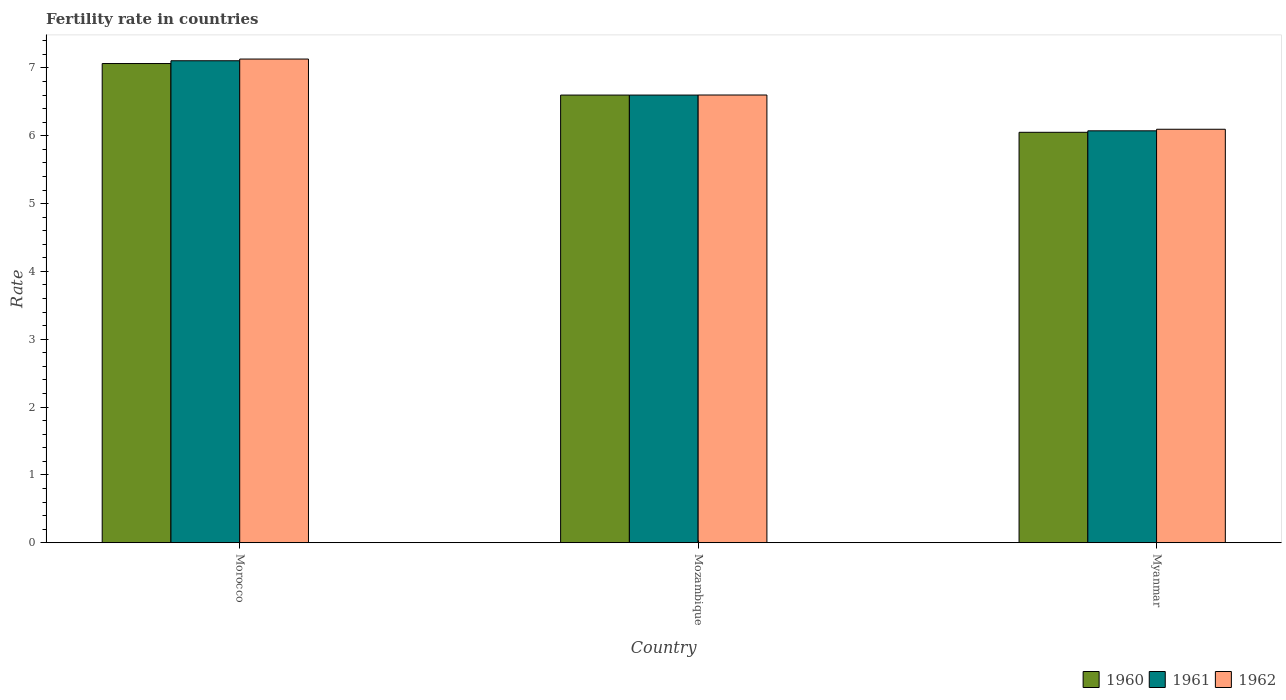How many groups of bars are there?
Give a very brief answer. 3. Are the number of bars on each tick of the X-axis equal?
Your answer should be compact. Yes. What is the label of the 1st group of bars from the left?
Provide a succinct answer. Morocco. What is the fertility rate in 1960 in Myanmar?
Make the answer very short. 6.05. Across all countries, what is the maximum fertility rate in 1960?
Your response must be concise. 7.07. Across all countries, what is the minimum fertility rate in 1961?
Offer a very short reply. 6.07. In which country was the fertility rate in 1962 maximum?
Keep it short and to the point. Morocco. In which country was the fertility rate in 1960 minimum?
Ensure brevity in your answer.  Myanmar. What is the total fertility rate in 1960 in the graph?
Offer a terse response. 19.72. What is the difference between the fertility rate in 1960 in Mozambique and that in Myanmar?
Offer a very short reply. 0.55. What is the difference between the fertility rate in 1960 in Myanmar and the fertility rate in 1961 in Mozambique?
Your response must be concise. -0.55. What is the average fertility rate in 1961 per country?
Provide a succinct answer. 6.59. What is the difference between the fertility rate of/in 1960 and fertility rate of/in 1961 in Mozambique?
Ensure brevity in your answer.  0. What is the ratio of the fertility rate in 1960 in Morocco to that in Myanmar?
Make the answer very short. 1.17. What is the difference between the highest and the second highest fertility rate in 1962?
Your answer should be compact. -0.5. What is the difference between the highest and the lowest fertility rate in 1960?
Keep it short and to the point. 1.01. In how many countries, is the fertility rate in 1961 greater than the average fertility rate in 1961 taken over all countries?
Your answer should be very brief. 2. What does the 1st bar from the right in Morocco represents?
Ensure brevity in your answer.  1962. Is it the case that in every country, the sum of the fertility rate in 1962 and fertility rate in 1960 is greater than the fertility rate in 1961?
Offer a terse response. Yes. Are all the bars in the graph horizontal?
Provide a short and direct response. No. How many countries are there in the graph?
Your answer should be compact. 3. Are the values on the major ticks of Y-axis written in scientific E-notation?
Provide a short and direct response. No. Does the graph contain any zero values?
Give a very brief answer. No. How many legend labels are there?
Your answer should be very brief. 3. How are the legend labels stacked?
Keep it short and to the point. Horizontal. What is the title of the graph?
Give a very brief answer. Fertility rate in countries. Does "1982" appear as one of the legend labels in the graph?
Give a very brief answer. No. What is the label or title of the X-axis?
Your answer should be very brief. Country. What is the label or title of the Y-axis?
Your response must be concise. Rate. What is the Rate of 1960 in Morocco?
Keep it short and to the point. 7.07. What is the Rate of 1961 in Morocco?
Your response must be concise. 7.11. What is the Rate of 1962 in Morocco?
Your answer should be very brief. 7.13. What is the Rate in 1961 in Mozambique?
Your answer should be very brief. 6.6. What is the Rate in 1962 in Mozambique?
Give a very brief answer. 6.6. What is the Rate of 1960 in Myanmar?
Your answer should be very brief. 6.05. What is the Rate in 1961 in Myanmar?
Your answer should be very brief. 6.07. What is the Rate of 1962 in Myanmar?
Provide a short and direct response. 6.1. Across all countries, what is the maximum Rate in 1960?
Your answer should be very brief. 7.07. Across all countries, what is the maximum Rate of 1961?
Give a very brief answer. 7.11. Across all countries, what is the maximum Rate in 1962?
Keep it short and to the point. 7.13. Across all countries, what is the minimum Rate in 1960?
Make the answer very short. 6.05. Across all countries, what is the minimum Rate of 1961?
Provide a short and direct response. 6.07. Across all countries, what is the minimum Rate of 1962?
Your response must be concise. 6.1. What is the total Rate of 1960 in the graph?
Offer a very short reply. 19.72. What is the total Rate of 1961 in the graph?
Keep it short and to the point. 19.78. What is the total Rate in 1962 in the graph?
Provide a succinct answer. 19.83. What is the difference between the Rate of 1960 in Morocco and that in Mozambique?
Keep it short and to the point. 0.47. What is the difference between the Rate in 1961 in Morocco and that in Mozambique?
Ensure brevity in your answer.  0.51. What is the difference between the Rate of 1962 in Morocco and that in Mozambique?
Provide a short and direct response. 0.53. What is the difference between the Rate in 1961 in Morocco and that in Myanmar?
Offer a terse response. 1.03. What is the difference between the Rate of 1962 in Morocco and that in Myanmar?
Keep it short and to the point. 1.03. What is the difference between the Rate in 1960 in Mozambique and that in Myanmar?
Offer a terse response. 0.55. What is the difference between the Rate of 1961 in Mozambique and that in Myanmar?
Ensure brevity in your answer.  0.53. What is the difference between the Rate in 1962 in Mozambique and that in Myanmar?
Offer a very short reply. 0.51. What is the difference between the Rate of 1960 in Morocco and the Rate of 1961 in Mozambique?
Offer a very short reply. 0.47. What is the difference between the Rate in 1960 in Morocco and the Rate in 1962 in Mozambique?
Keep it short and to the point. 0.46. What is the difference between the Rate of 1961 in Morocco and the Rate of 1962 in Mozambique?
Your answer should be very brief. 0.51. What is the difference between the Rate of 1960 in Morocco and the Rate of 1961 in Myanmar?
Your answer should be very brief. 0.99. What is the difference between the Rate in 1960 in Morocco and the Rate in 1962 in Myanmar?
Provide a short and direct response. 0.97. What is the difference between the Rate in 1961 in Morocco and the Rate in 1962 in Myanmar?
Your answer should be compact. 1.01. What is the difference between the Rate of 1960 in Mozambique and the Rate of 1961 in Myanmar?
Your response must be concise. 0.53. What is the difference between the Rate of 1960 in Mozambique and the Rate of 1962 in Myanmar?
Your answer should be very brief. 0.5. What is the difference between the Rate in 1961 in Mozambique and the Rate in 1962 in Myanmar?
Your answer should be very brief. 0.5. What is the average Rate in 1960 per country?
Make the answer very short. 6.57. What is the average Rate of 1961 per country?
Offer a very short reply. 6.59. What is the average Rate in 1962 per country?
Your response must be concise. 6.61. What is the difference between the Rate in 1960 and Rate in 1961 in Morocco?
Provide a short and direct response. -0.04. What is the difference between the Rate of 1960 and Rate of 1962 in Morocco?
Provide a succinct answer. -0.07. What is the difference between the Rate in 1961 and Rate in 1962 in Morocco?
Make the answer very short. -0.03. What is the difference between the Rate of 1960 and Rate of 1962 in Mozambique?
Your answer should be compact. -0. What is the difference between the Rate of 1961 and Rate of 1962 in Mozambique?
Keep it short and to the point. -0. What is the difference between the Rate in 1960 and Rate in 1961 in Myanmar?
Make the answer very short. -0.02. What is the difference between the Rate of 1960 and Rate of 1962 in Myanmar?
Ensure brevity in your answer.  -0.04. What is the difference between the Rate of 1961 and Rate of 1962 in Myanmar?
Provide a short and direct response. -0.02. What is the ratio of the Rate of 1960 in Morocco to that in Mozambique?
Offer a terse response. 1.07. What is the ratio of the Rate in 1961 in Morocco to that in Mozambique?
Keep it short and to the point. 1.08. What is the ratio of the Rate in 1962 in Morocco to that in Mozambique?
Provide a short and direct response. 1.08. What is the ratio of the Rate of 1960 in Morocco to that in Myanmar?
Provide a short and direct response. 1.17. What is the ratio of the Rate of 1961 in Morocco to that in Myanmar?
Ensure brevity in your answer.  1.17. What is the ratio of the Rate in 1962 in Morocco to that in Myanmar?
Your response must be concise. 1.17. What is the ratio of the Rate of 1960 in Mozambique to that in Myanmar?
Provide a short and direct response. 1.09. What is the ratio of the Rate in 1961 in Mozambique to that in Myanmar?
Your answer should be compact. 1.09. What is the ratio of the Rate of 1962 in Mozambique to that in Myanmar?
Offer a terse response. 1.08. What is the difference between the highest and the second highest Rate of 1960?
Keep it short and to the point. 0.47. What is the difference between the highest and the second highest Rate of 1961?
Provide a succinct answer. 0.51. What is the difference between the highest and the second highest Rate in 1962?
Make the answer very short. 0.53. What is the difference between the highest and the lowest Rate in 1960?
Your answer should be compact. 1.01. What is the difference between the highest and the lowest Rate of 1961?
Make the answer very short. 1.03. What is the difference between the highest and the lowest Rate in 1962?
Give a very brief answer. 1.03. 